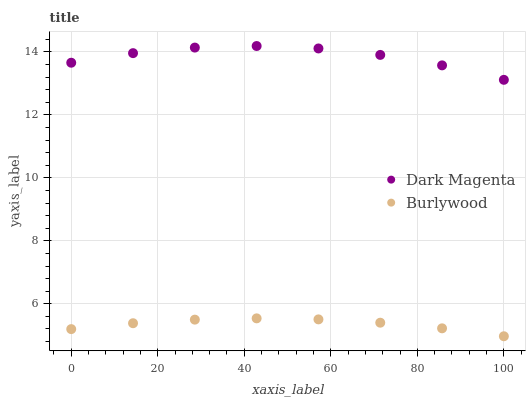Does Burlywood have the minimum area under the curve?
Answer yes or no. Yes. Does Dark Magenta have the maximum area under the curve?
Answer yes or no. Yes. Does Dark Magenta have the minimum area under the curve?
Answer yes or no. No. Is Burlywood the smoothest?
Answer yes or no. Yes. Is Dark Magenta the roughest?
Answer yes or no. Yes. Is Dark Magenta the smoothest?
Answer yes or no. No. Does Burlywood have the lowest value?
Answer yes or no. Yes. Does Dark Magenta have the lowest value?
Answer yes or no. No. Does Dark Magenta have the highest value?
Answer yes or no. Yes. Is Burlywood less than Dark Magenta?
Answer yes or no. Yes. Is Dark Magenta greater than Burlywood?
Answer yes or no. Yes. Does Burlywood intersect Dark Magenta?
Answer yes or no. No. 